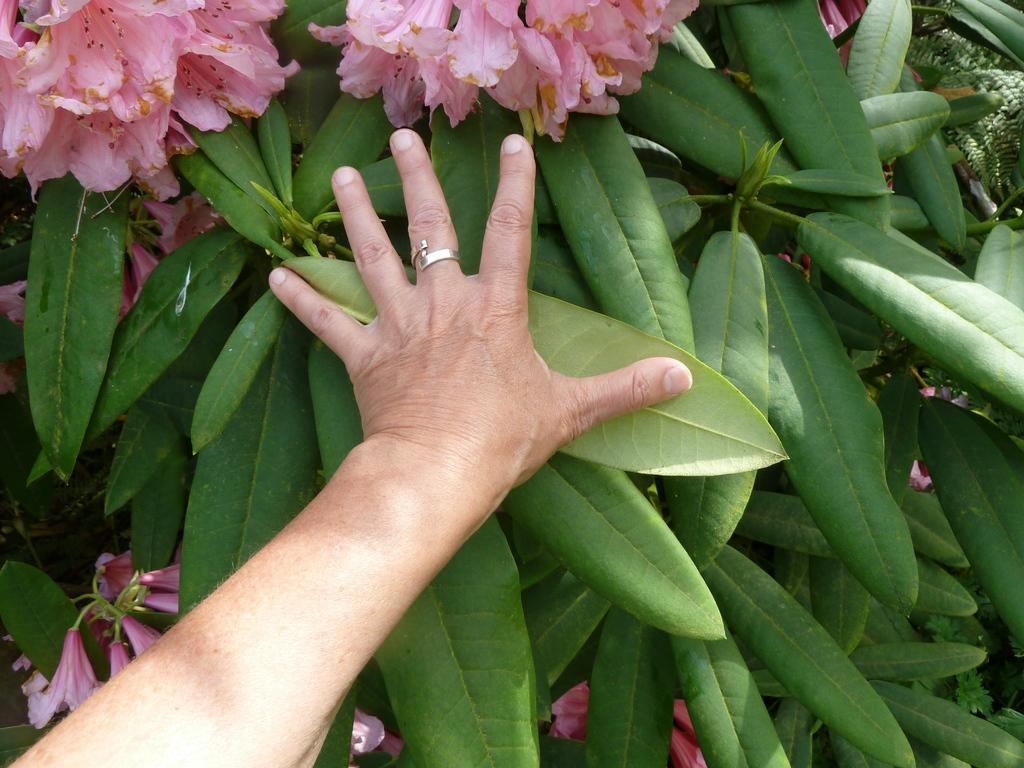What part of a person can be seen in the image? There is a person's hand in the image. What type of plant material is present in the image? There are leaves and flowers in the image. What type of disease is being treated in the image? There is no indication of a disease or treatment in the image; it only shows a person's hand, leaves, and flowers. 